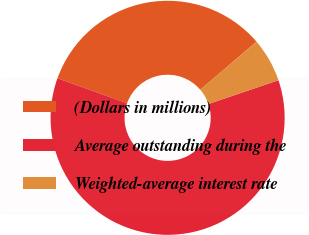Convert chart. <chart><loc_0><loc_0><loc_500><loc_500><pie_chart><fcel>(Dollars in millions)<fcel>Average outstanding during the<fcel>Weighted-average interest rate<nl><fcel>33.24%<fcel>60.69%<fcel>6.07%<nl></chart> 